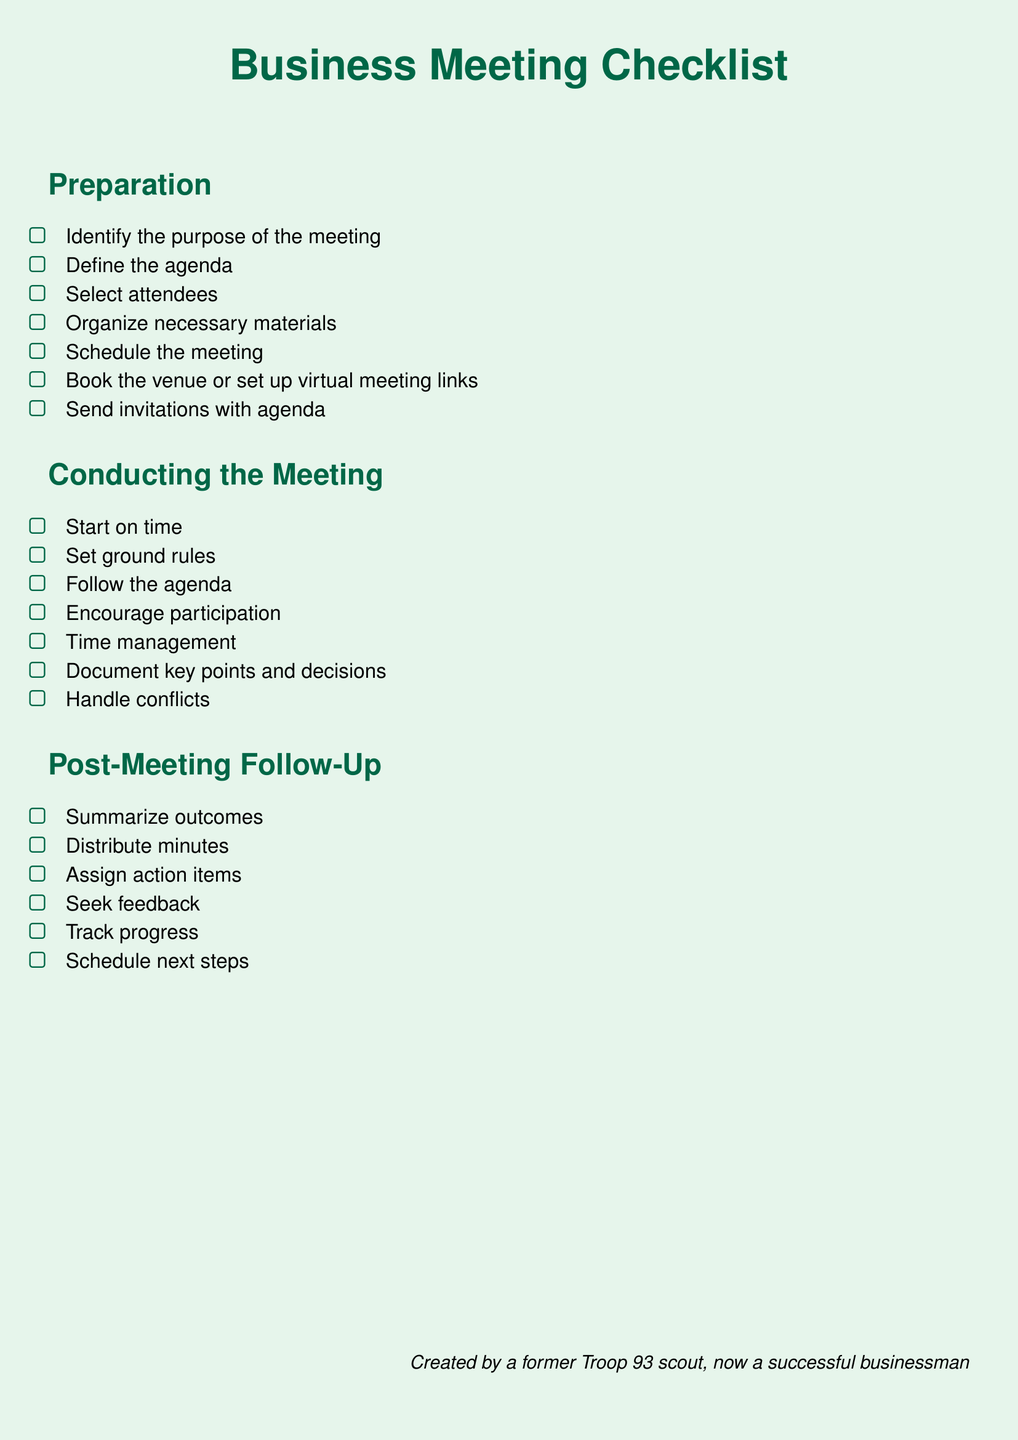What is the title of the document? The title is prominently displayed at the top of the document in a large font, indicating the purpose.
Answer: Business Meeting Checklist How many main sections are in the checklist? The document is divided into three clear sections, outlining the primary stages of a business meeting.
Answer: Three What is the first item in the Preparation section? Items are listed with checkboxes, and the first item is typically important for meeting success.
Answer: Identify the purpose of the meeting What must be done after the meeting according to the checklist? The checklist includes post-meeting activities essential for effective follow-up and accountability.
Answer: Summarize outcomes Which section contains the item about managing time? Each section serves a different purpose, and time management is crucial for maintaining flow during a meeting.
Answer: Conducting the Meeting What color is used for the section titles? The document has a consistent color scheme for section titles, enhancing visual clarity.
Answer: Scout What is the last action item mentioned in the Post-Meeting Follow-Up section? This item is related to planning for ongoing efforts after the conclusion of a meeting.
Answer: Schedule next steps How should ground rules be established according to the checklist? This is a crucial step for ensuring a respectful and productive discussion in the meeting.
Answer: Set ground rules What is indicated by the footer note? The note reflects the author's background, adding a personal touch to the document.
Answer: Created by a former Troop 93 scout, now a successful businessman 